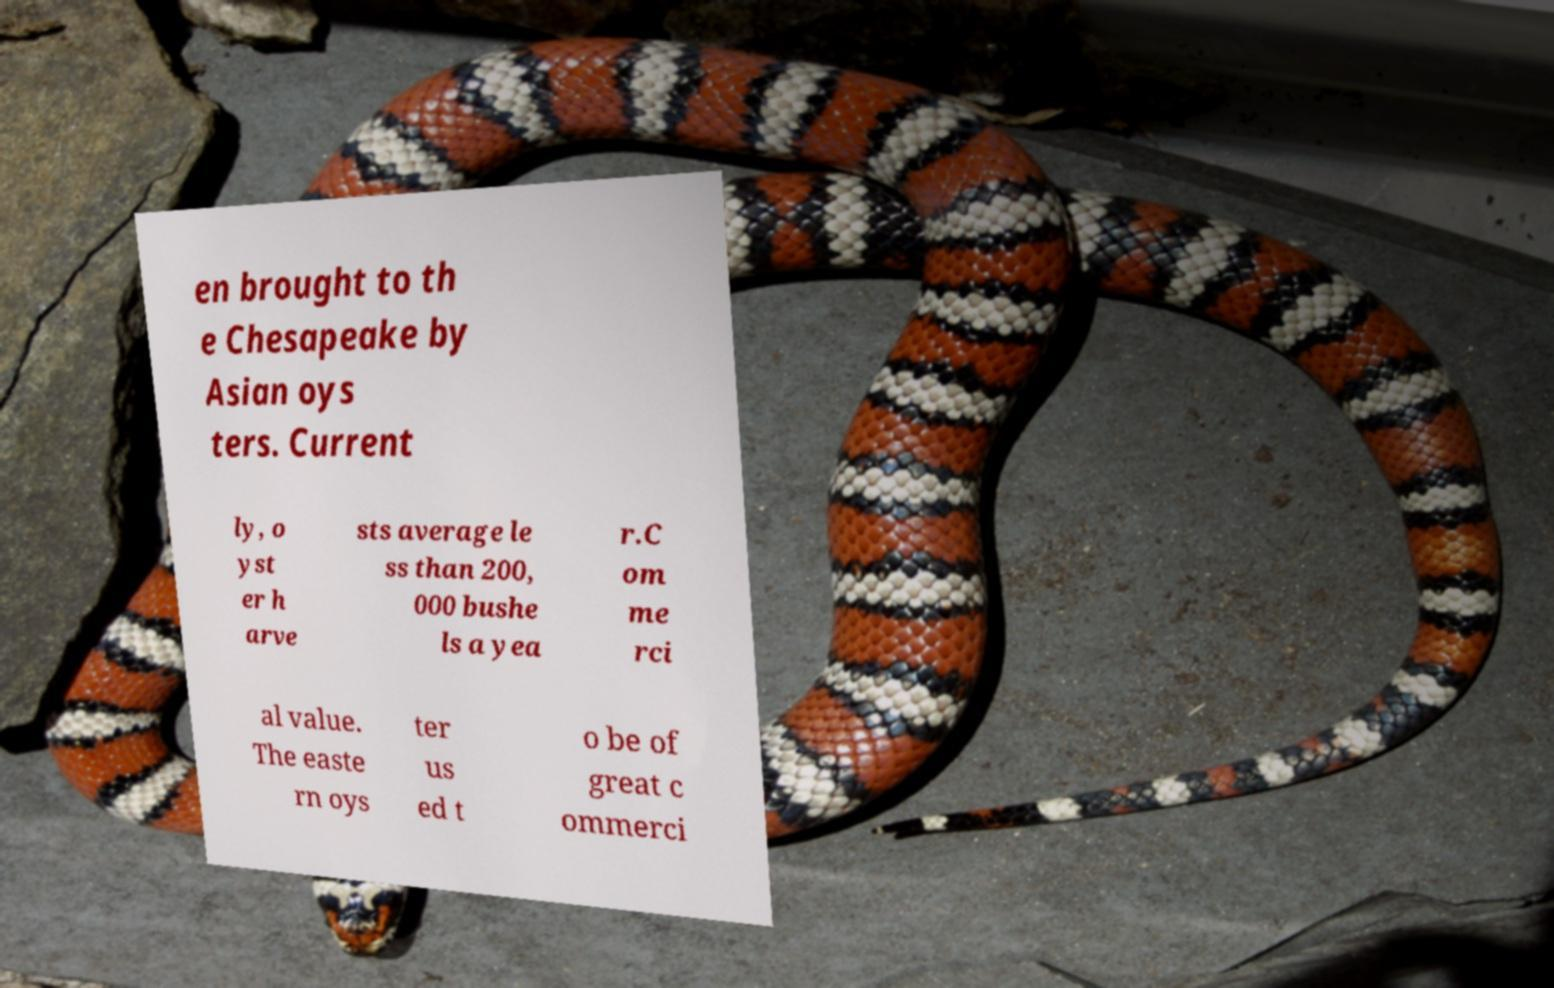For documentation purposes, I need the text within this image transcribed. Could you provide that? en brought to th e Chesapeake by Asian oys ters. Current ly, o yst er h arve sts average le ss than 200, 000 bushe ls a yea r.C om me rci al value. The easte rn oys ter us ed t o be of great c ommerci 